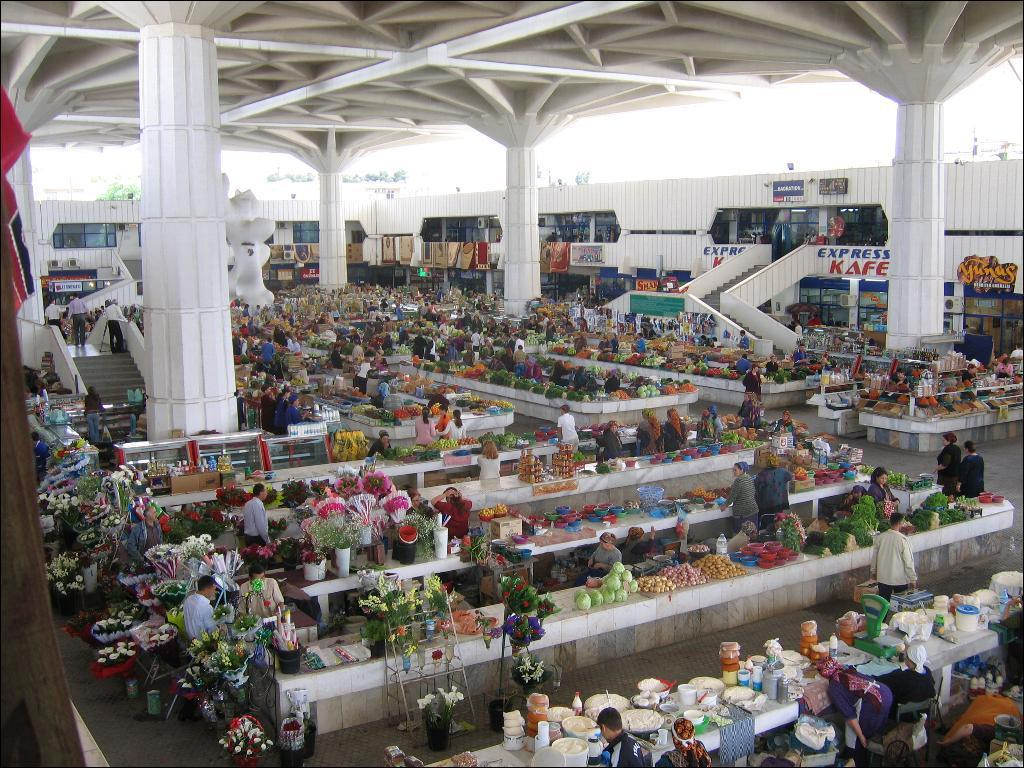Provide a one-sentence caption for the provided image. An indoor farmers marlet with lots of produce displayed and an express kafe next to a staircase. 